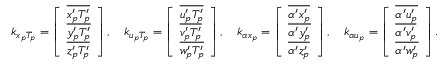Convert formula to latex. <formula><loc_0><loc_0><loc_500><loc_500>\begin{array} { r } { k _ { x _ { p } T _ { p } } = \left [ \begin{array} { l } { \overline { { { x _ { p } ^ { \prime } } T _ { p } ^ { \prime } } } } \\ { \overline { { { y _ { p } ^ { \prime } } T _ { p } ^ { \prime } } } } \\ { \overline { { { z _ { p } ^ { \prime } } T _ { p } ^ { \prime } } } } \end{array} \right ] , \quad k _ { u _ { p } T _ { p } } = \left [ \begin{array} { l } { \overline { { { u _ { p } ^ { \prime } } T _ { p } ^ { \prime } } } } \\ { \overline { { { v _ { p } ^ { \prime } } T _ { p } ^ { \prime } } } } \\ { \overline { { { w _ { p } ^ { \prime } } T _ { p } ^ { \prime } } } } \end{array} \right ] , \quad k _ { \alpha x _ { p } } = \left [ \begin{array} { l } { \overline { { \alpha ^ { \prime } { x _ { p } ^ { \prime } } } } } \\ { \overline { { \alpha ^ { \prime } { y _ { p } ^ { \prime } } } } } \\ { \overline { { \alpha ^ { \prime } { z _ { p } ^ { \prime } } } } } \end{array} \right ] , \quad k _ { \alpha u _ { p } } = \left [ \begin{array} { l } { \overline { { \alpha ^ { \prime } { u _ { p } ^ { \prime } } } } } \\ { \overline { { \alpha ^ { \prime } { v _ { p } ^ { \prime } } } } } \\ { \overline { { \alpha ^ { \prime } { w _ { p } ^ { \prime } } } } } \end{array} \right ] . } \end{array}</formula> 